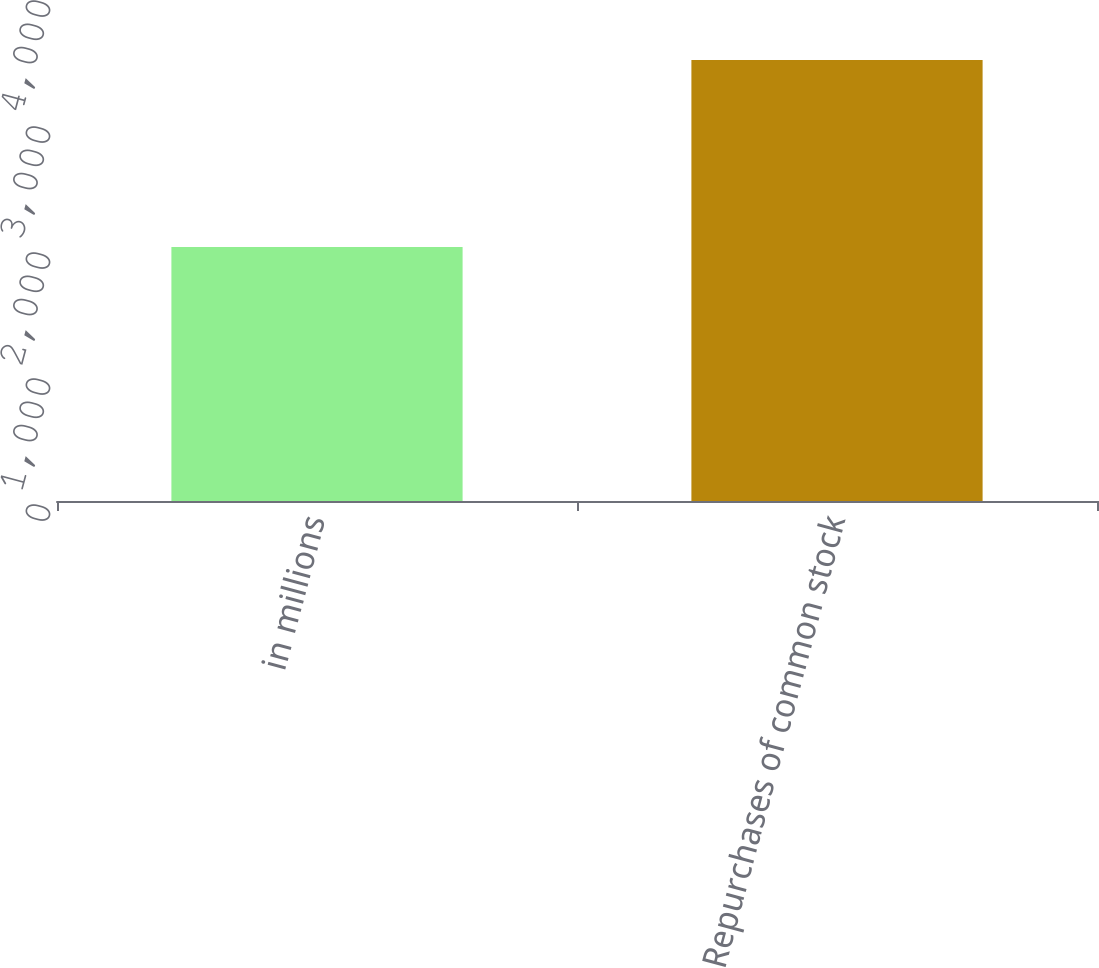Convert chart. <chart><loc_0><loc_0><loc_500><loc_500><bar_chart><fcel>in millions<fcel>Repurchases of common stock<nl><fcel>2016<fcel>3500<nl></chart> 